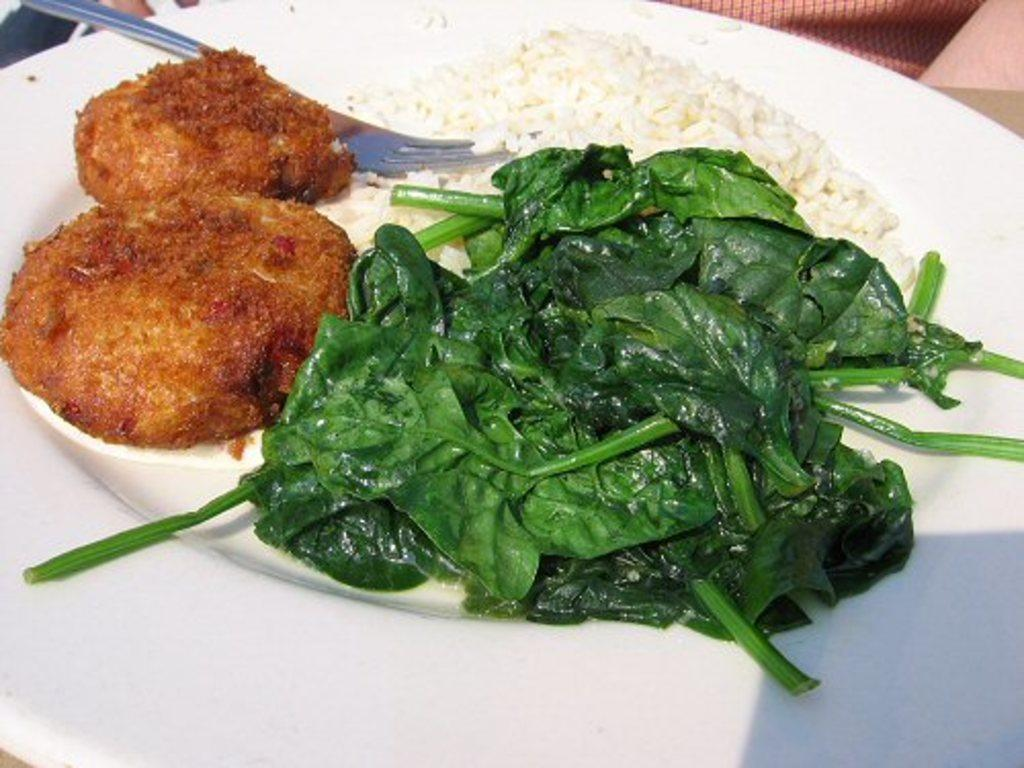What is on the plate that is visible in the image? The plate contains rice, spinach, and two nuggets. What utensil is on the plate? There is a fork on the plate. What is the person at the top of the image doing? The facts provided do not specify what the person is doing. How many items are on the plate? There are four items on the plate: rice, spinach, two nuggets, and a fork. How many horses can be seen grazing in the image? There are no horses present in the image. What type of squirrel is sitting on the plate? There is no squirrel present in the image. 